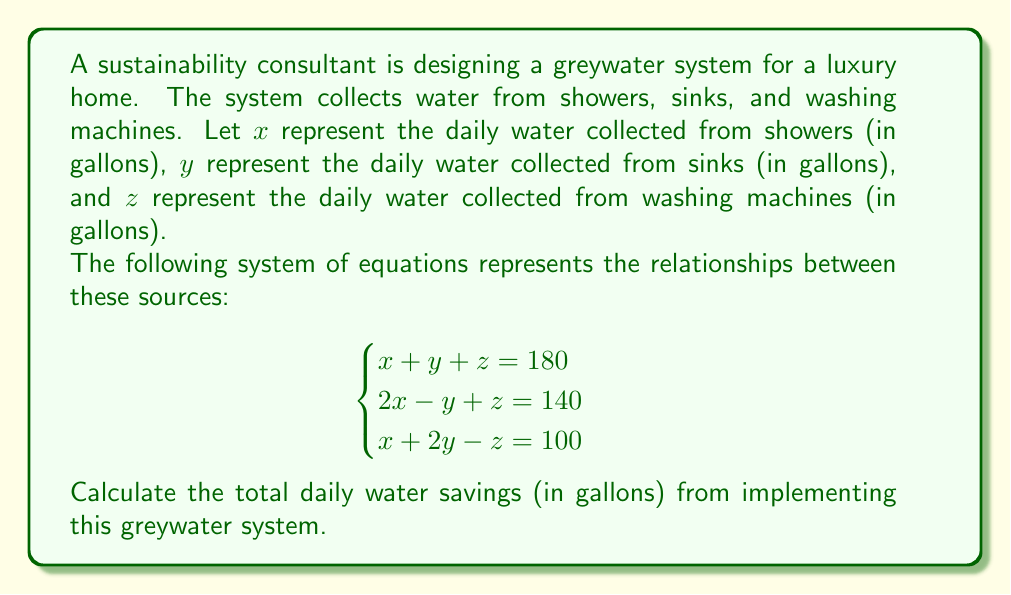Can you solve this math problem? To solve this problem, we need to use the system of equations to find the values of $x$, $y$, and $z$, which represent the daily water collected from showers, sinks, and washing machines, respectively.

Let's solve the system of equations using elimination method:

1) From equation 1, express $z$ in terms of $x$ and $y$:
   $z = 180 - x - y$ (Equation 4)

2) Substitute this into equation 2:
   $2x - y + (180 - x - y) = 140$
   $x - 2y = -40$ (Equation 5)

3) Substitute equation 4 into equation 3:
   $x + 2y - (180 - x - y) = 100$
   $2x + 3y = 280$ (Equation 6)

4) Now we have two equations with two unknowns (equations 5 and 6):
   $x - 2y = -40$
   $2x + 3y = 280$

5) Multiply equation 5 by 2 and add it to equation 6:
   $2x - 4y = -80$
   $2x + 3y = 280$
   $-y = 200$
   $y = -200$

6) Substitute $y = -200$ into equation 5:
   $x - 2(-200) = -40$
   $x + 400 = -40$
   $x = -440$

7) Now we can find $z$ using equation 4:
   $z = 180 - (-440) - (-200) = 820$

8) Let's verify our solution satisfies all three original equations:
   $-440 + (-200) + 820 = 180$ (✓)
   $2(-440) - (-200) + 820 = 140$ (✓)
   $-440 + 2(-200) - 820 = 100$ (✓)

The total daily water savings is the sum of water collected from all three sources:
$x + y + z = -440 + (-200) + 820 = 180$ gallons
Answer: The total daily water savings from implementing the greywater system is 180 gallons. 